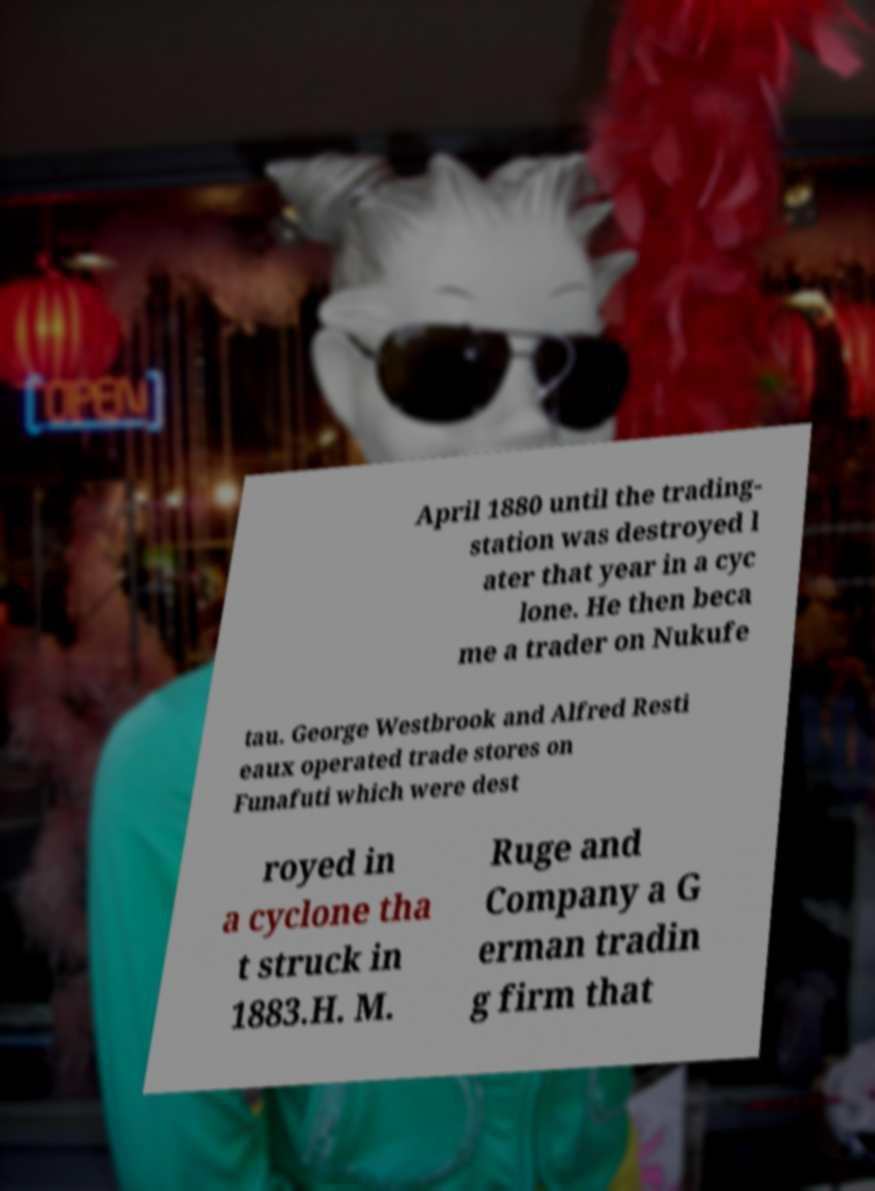Please read and relay the text visible in this image. What does it say? April 1880 until the trading- station was destroyed l ater that year in a cyc lone. He then beca me a trader on Nukufe tau. George Westbrook and Alfred Resti eaux operated trade stores on Funafuti which were dest royed in a cyclone tha t struck in 1883.H. M. Ruge and Company a G erman tradin g firm that 